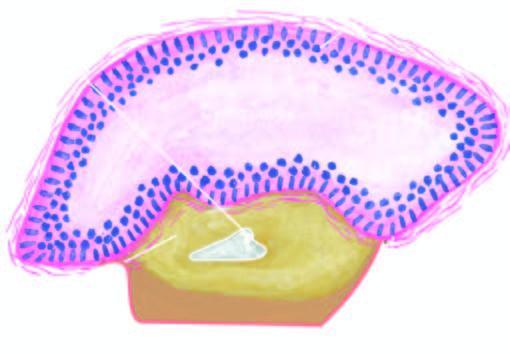s a partly formed unerupted tooth also seen in the wall?
Answer the question using a single word or phrase. Yes 